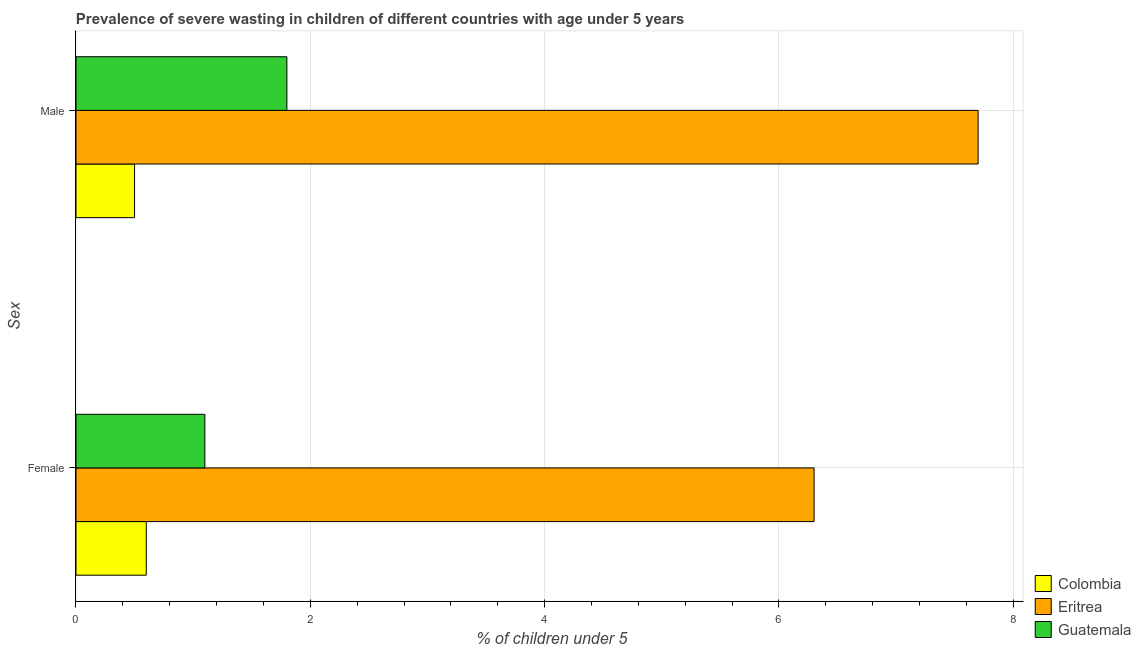How many different coloured bars are there?
Keep it short and to the point. 3. How many groups of bars are there?
Make the answer very short. 2. Are the number of bars per tick equal to the number of legend labels?
Provide a short and direct response. Yes. Are the number of bars on each tick of the Y-axis equal?
Your answer should be compact. Yes. How many bars are there on the 1st tick from the bottom?
Your answer should be compact. 3. What is the label of the 1st group of bars from the top?
Give a very brief answer. Male. What is the percentage of undernourished female children in Guatemala?
Provide a short and direct response. 1.1. Across all countries, what is the maximum percentage of undernourished female children?
Ensure brevity in your answer.  6.3. Across all countries, what is the minimum percentage of undernourished male children?
Your answer should be very brief. 0.5. In which country was the percentage of undernourished female children maximum?
Offer a terse response. Eritrea. What is the total percentage of undernourished female children in the graph?
Your answer should be compact. 8. What is the difference between the percentage of undernourished female children in Guatemala and that in Eritrea?
Provide a short and direct response. -5.2. What is the difference between the percentage of undernourished female children in Eritrea and the percentage of undernourished male children in Guatemala?
Provide a succinct answer. 4.5. What is the average percentage of undernourished female children per country?
Offer a terse response. 2.67. What is the difference between the percentage of undernourished male children and percentage of undernourished female children in Colombia?
Offer a very short reply. -0.1. What is the ratio of the percentage of undernourished male children in Eritrea to that in Colombia?
Your response must be concise. 15.4. What does the 2nd bar from the top in Female represents?
Your response must be concise. Eritrea. What does the 3rd bar from the bottom in Male represents?
Your answer should be very brief. Guatemala. How many bars are there?
Your answer should be very brief. 6. How many countries are there in the graph?
Ensure brevity in your answer.  3. What is the difference between two consecutive major ticks on the X-axis?
Ensure brevity in your answer.  2. Does the graph contain any zero values?
Make the answer very short. No. Where does the legend appear in the graph?
Offer a terse response. Bottom right. How are the legend labels stacked?
Your response must be concise. Vertical. What is the title of the graph?
Ensure brevity in your answer.  Prevalence of severe wasting in children of different countries with age under 5 years. What is the label or title of the X-axis?
Your answer should be compact.  % of children under 5. What is the label or title of the Y-axis?
Your answer should be very brief. Sex. What is the  % of children under 5 of Colombia in Female?
Make the answer very short. 0.6. What is the  % of children under 5 in Eritrea in Female?
Your response must be concise. 6.3. What is the  % of children under 5 of Guatemala in Female?
Ensure brevity in your answer.  1.1. What is the  % of children under 5 in Colombia in Male?
Give a very brief answer. 0.5. What is the  % of children under 5 of Eritrea in Male?
Give a very brief answer. 7.7. What is the  % of children under 5 of Guatemala in Male?
Ensure brevity in your answer.  1.8. Across all Sex, what is the maximum  % of children under 5 of Colombia?
Keep it short and to the point. 0.6. Across all Sex, what is the maximum  % of children under 5 in Eritrea?
Offer a very short reply. 7.7. Across all Sex, what is the maximum  % of children under 5 in Guatemala?
Provide a short and direct response. 1.8. Across all Sex, what is the minimum  % of children under 5 in Colombia?
Your answer should be compact. 0.5. Across all Sex, what is the minimum  % of children under 5 in Eritrea?
Your answer should be very brief. 6.3. Across all Sex, what is the minimum  % of children under 5 in Guatemala?
Make the answer very short. 1.1. What is the total  % of children under 5 of Colombia in the graph?
Keep it short and to the point. 1.1. What is the total  % of children under 5 of Eritrea in the graph?
Provide a short and direct response. 14. What is the total  % of children under 5 of Guatemala in the graph?
Provide a succinct answer. 2.9. What is the difference between the  % of children under 5 of Colombia in Female and the  % of children under 5 of Guatemala in Male?
Make the answer very short. -1.2. What is the average  % of children under 5 of Colombia per Sex?
Keep it short and to the point. 0.55. What is the average  % of children under 5 in Eritrea per Sex?
Give a very brief answer. 7. What is the average  % of children under 5 in Guatemala per Sex?
Make the answer very short. 1.45. What is the difference between the  % of children under 5 in Colombia and  % of children under 5 in Guatemala in Female?
Your response must be concise. -0.5. What is the difference between the  % of children under 5 of Eritrea and  % of children under 5 of Guatemala in Male?
Your answer should be very brief. 5.9. What is the ratio of the  % of children under 5 in Eritrea in Female to that in Male?
Ensure brevity in your answer.  0.82. What is the ratio of the  % of children under 5 of Guatemala in Female to that in Male?
Keep it short and to the point. 0.61. What is the difference between the highest and the second highest  % of children under 5 in Eritrea?
Give a very brief answer. 1.4. What is the difference between the highest and the second highest  % of children under 5 of Guatemala?
Your response must be concise. 0.7. What is the difference between the highest and the lowest  % of children under 5 in Colombia?
Your answer should be compact. 0.1. What is the difference between the highest and the lowest  % of children under 5 of Eritrea?
Provide a short and direct response. 1.4. 